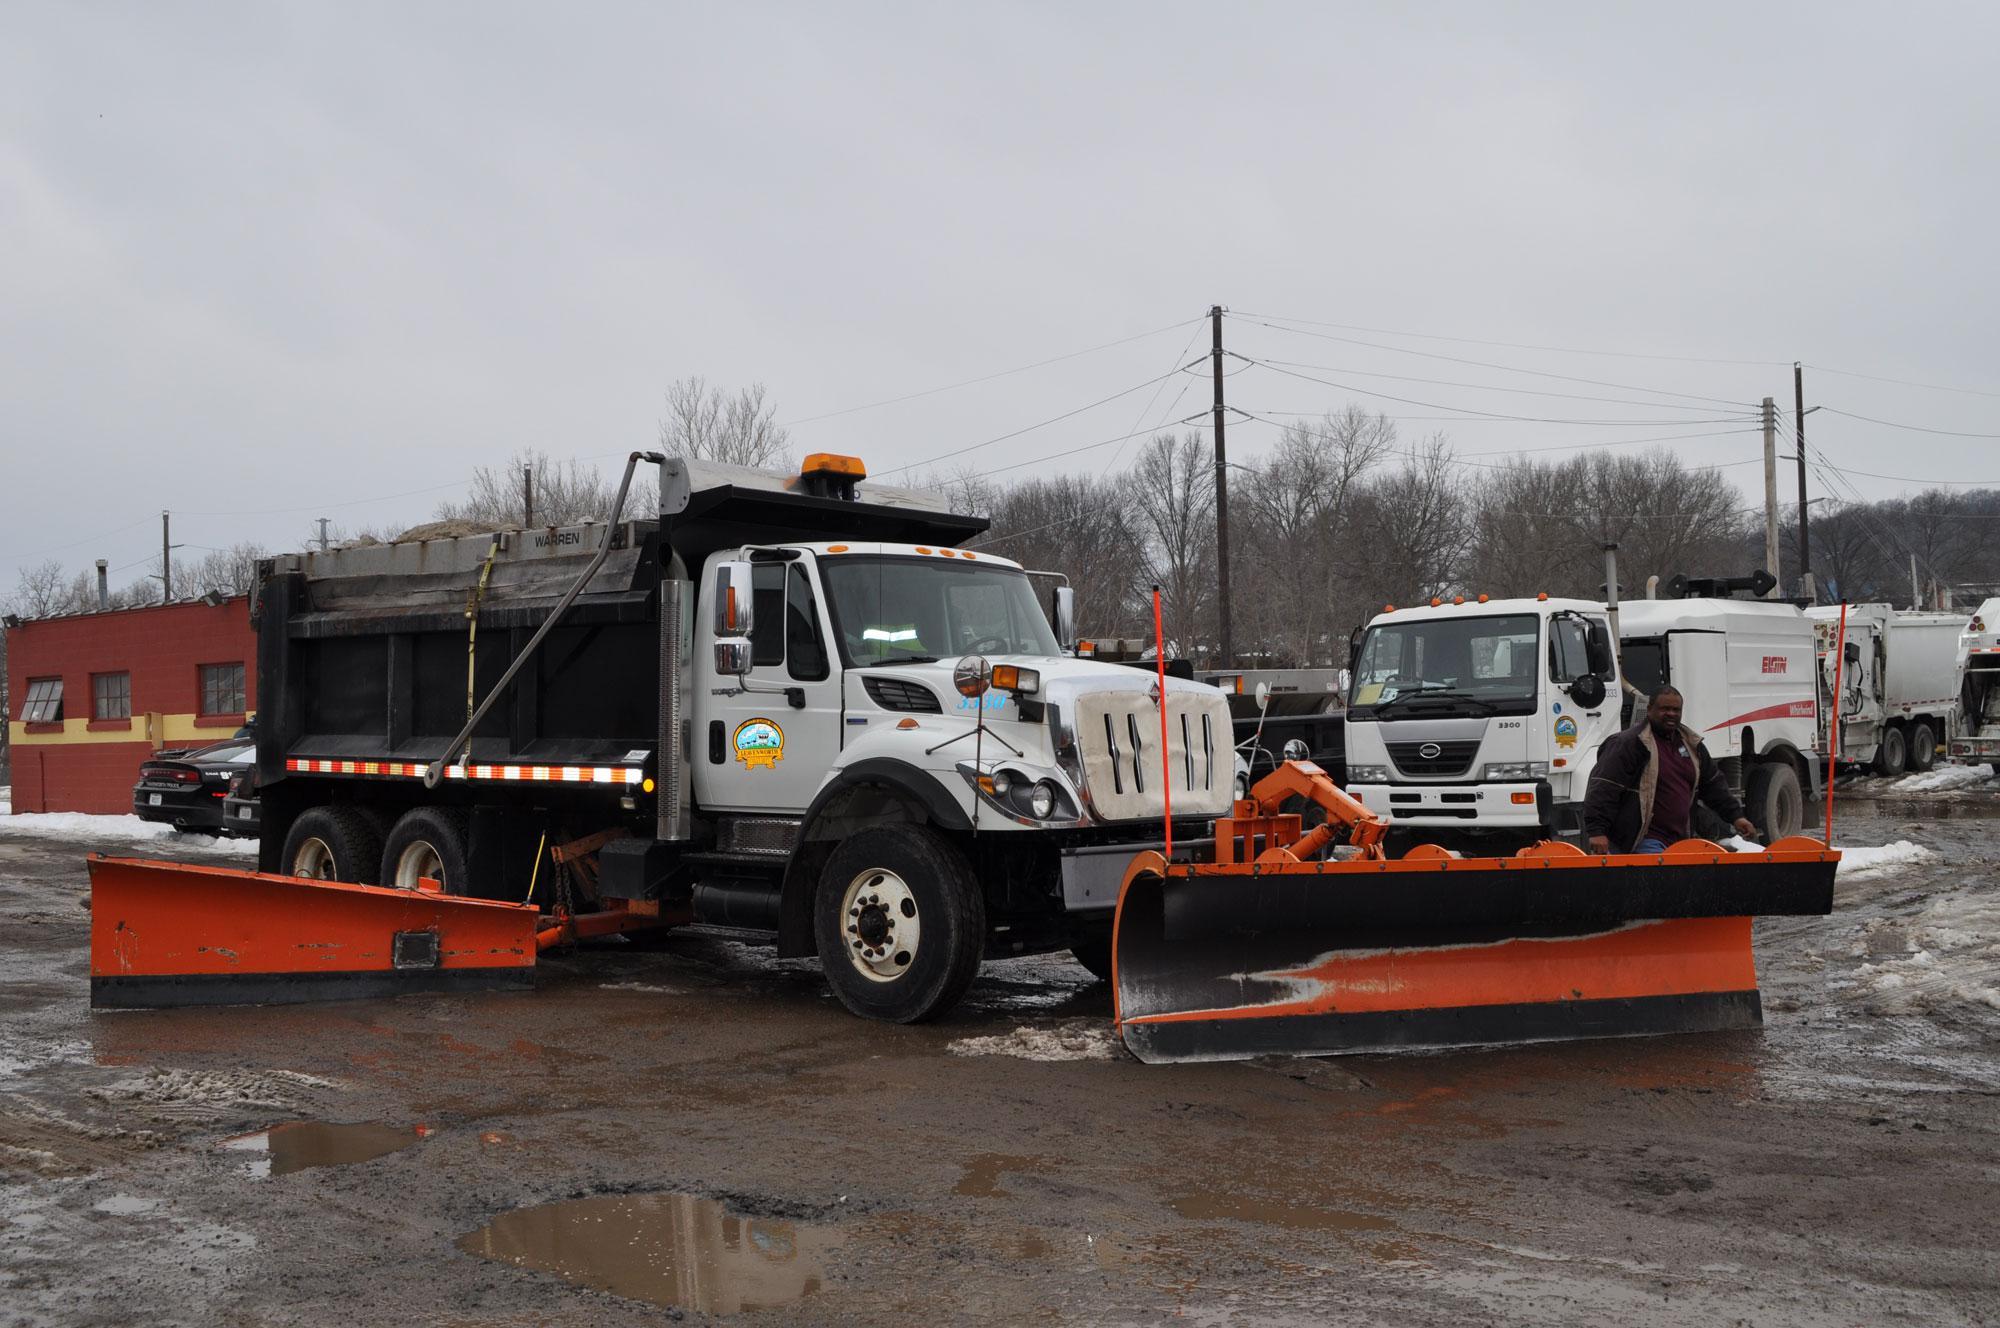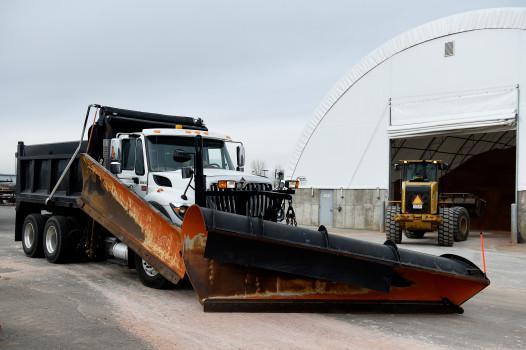The first image is the image on the left, the second image is the image on the right. Evaluate the accuracy of this statement regarding the images: "The image on the right contains an orange truck.". Is it true? Answer yes or no. No. 